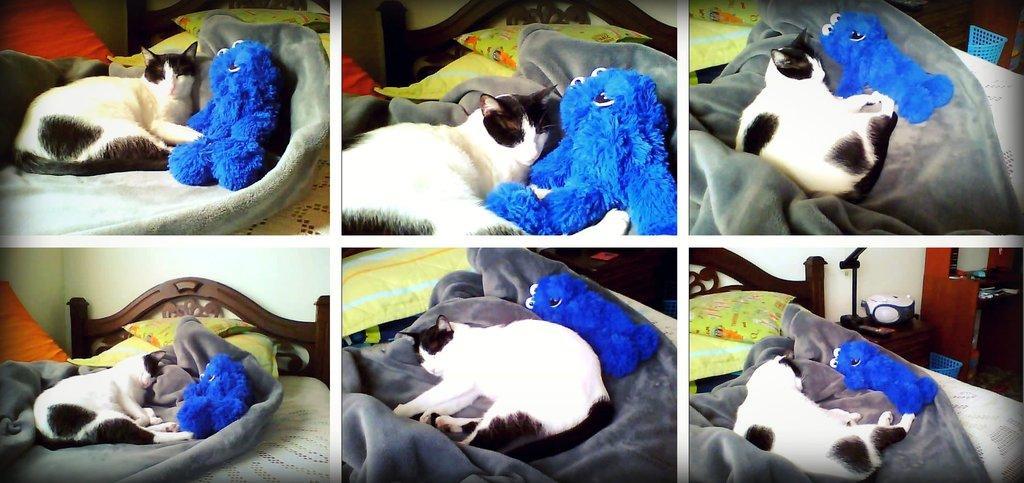Describe this image in one or two sentences. This is an edited picture. In this picture, we see six images collages. Here, we see a cat lying on the bed beside the blue color toy. In all the images, we see cat lying on the bed beside the blue color toy but in different angles. In the right bottom of the picture, we see a table on which box is placed. Beside that, we see a cupboard and a blue basket. 